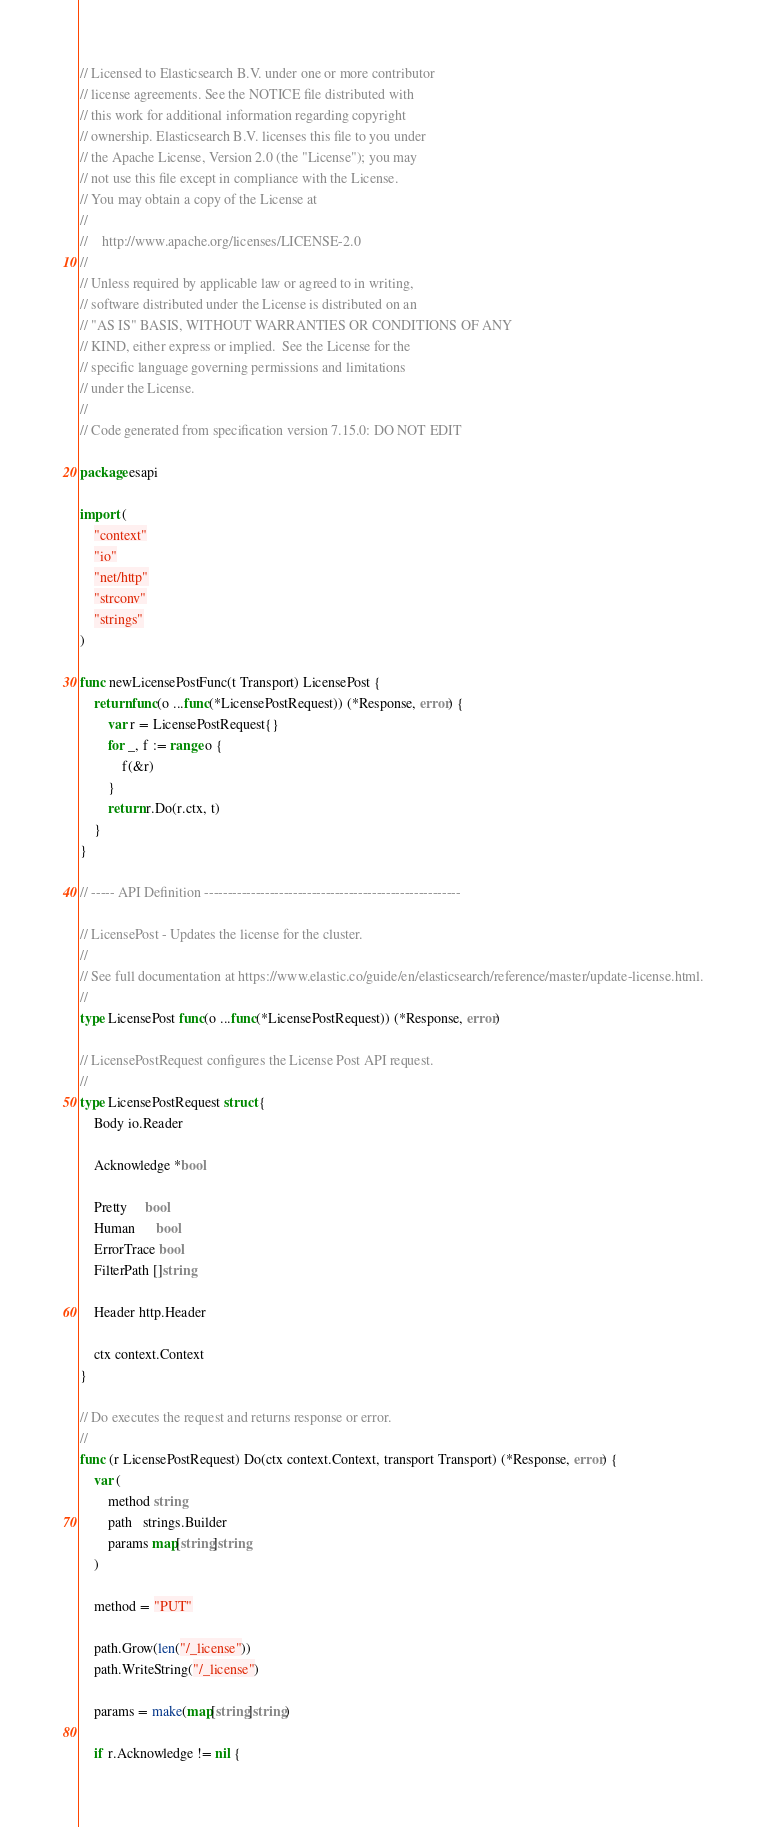Convert code to text. <code><loc_0><loc_0><loc_500><loc_500><_Go_>// Licensed to Elasticsearch B.V. under one or more contributor
// license agreements. See the NOTICE file distributed with
// this work for additional information regarding copyright
// ownership. Elasticsearch B.V. licenses this file to you under
// the Apache License, Version 2.0 (the "License"); you may
// not use this file except in compliance with the License.
// You may obtain a copy of the License at
//
//    http://www.apache.org/licenses/LICENSE-2.0
//
// Unless required by applicable law or agreed to in writing,
// software distributed under the License is distributed on an
// "AS IS" BASIS, WITHOUT WARRANTIES OR CONDITIONS OF ANY
// KIND, either express or implied.  See the License for the
// specific language governing permissions and limitations
// under the License.
//
// Code generated from specification version 7.15.0: DO NOT EDIT

package esapi

import (
	"context"
	"io"
	"net/http"
	"strconv"
	"strings"
)

func newLicensePostFunc(t Transport) LicensePost {
	return func(o ...func(*LicensePostRequest)) (*Response, error) {
		var r = LicensePostRequest{}
		for _, f := range o {
			f(&r)
		}
		return r.Do(r.ctx, t)
	}
}

// ----- API Definition -------------------------------------------------------

// LicensePost - Updates the license for the cluster.
//
// See full documentation at https://www.elastic.co/guide/en/elasticsearch/reference/master/update-license.html.
//
type LicensePost func(o ...func(*LicensePostRequest)) (*Response, error)

// LicensePostRequest configures the License Post API request.
//
type LicensePostRequest struct {
	Body io.Reader

	Acknowledge *bool

	Pretty     bool
	Human      bool
	ErrorTrace bool
	FilterPath []string

	Header http.Header

	ctx context.Context
}

// Do executes the request and returns response or error.
//
func (r LicensePostRequest) Do(ctx context.Context, transport Transport) (*Response, error) {
	var (
		method string
		path   strings.Builder
		params map[string]string
	)

	method = "PUT"

	path.Grow(len("/_license"))
	path.WriteString("/_license")

	params = make(map[string]string)

	if r.Acknowledge != nil {</code> 